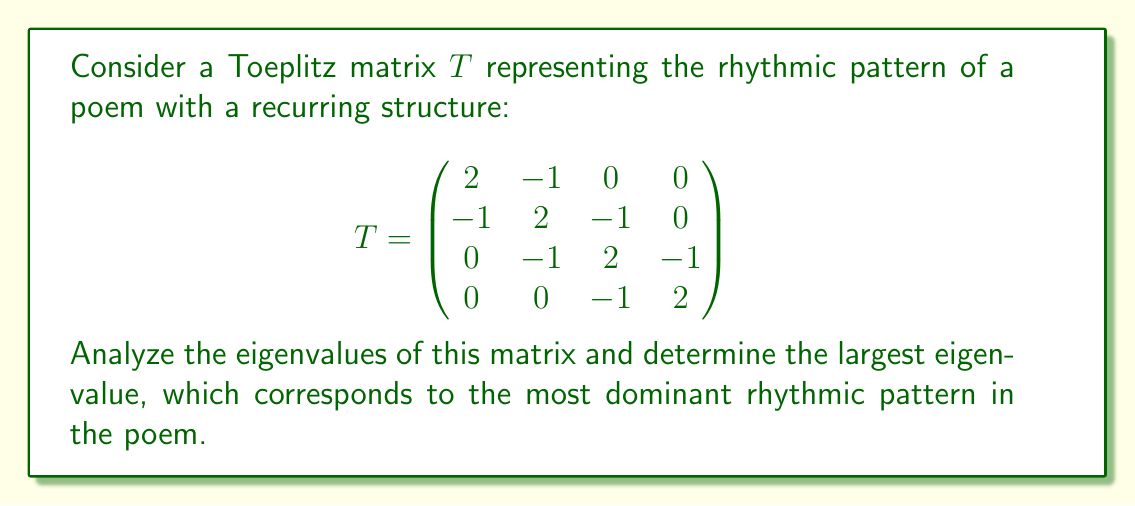Can you answer this question? To find the eigenvalues of the Toeplitz matrix T, we follow these steps:

1) For a Toeplitz matrix of this form, the eigenvalues are given by the formula:

   $$\lambda_k = 2 - 2\cos\left(\frac{k\pi}{n+1}\right)$$

   where $n$ is the size of the matrix (in this case, $n=4$) and $k = 1, 2, ..., n$.

2) Let's calculate the eigenvalues:

   For $k = 1$: 
   $$\lambda_1 = 2 - 2\cos\left(\frac{\pi}{5}\right) \approx 0.3820$$

   For $k = 2$:
   $$\lambda_2 = 2 - 2\cos\left(\frac{2\pi}{5}\right) \approx 1.3820$$

   For $k = 3$:
   $$\lambda_3 = 2 - 2\cos\left(\frac{3\pi}{5}\right) \approx 2.6180$$

   For $k = 4$:
   $$\lambda_4 = 2 - 2\cos\left(\frac{4\pi}{5}\right) \approx 3.6180$$

3) The largest eigenvalue is $\lambda_4 \approx 3.6180$.

This largest eigenvalue corresponds to the most dominant rhythmic pattern in the poem, representing the strongest repetitive structure in the verse.
Answer: $3.6180$ 